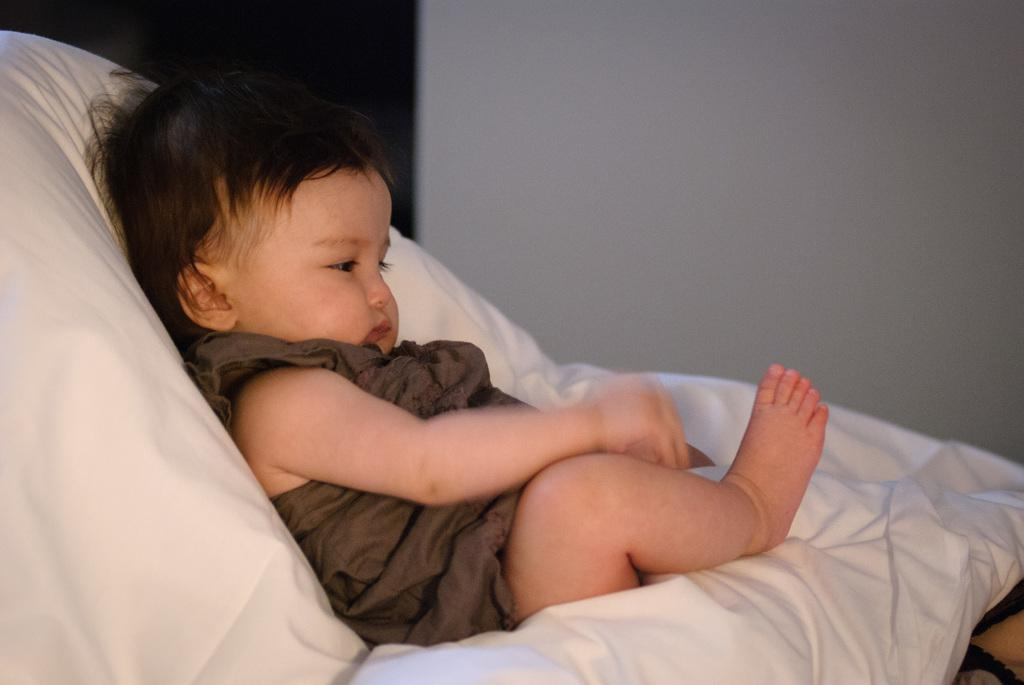What is the main subject of the image? There is a baby in the image. What is the baby resting on? The baby is on a white cloth. What can be seen in the background of the image? There is a wall in the background of the image. How many eyes does the baby's sister have in the image? There is no mention of a sister in the image, so we cannot determine the number of eyes the sister might have. 